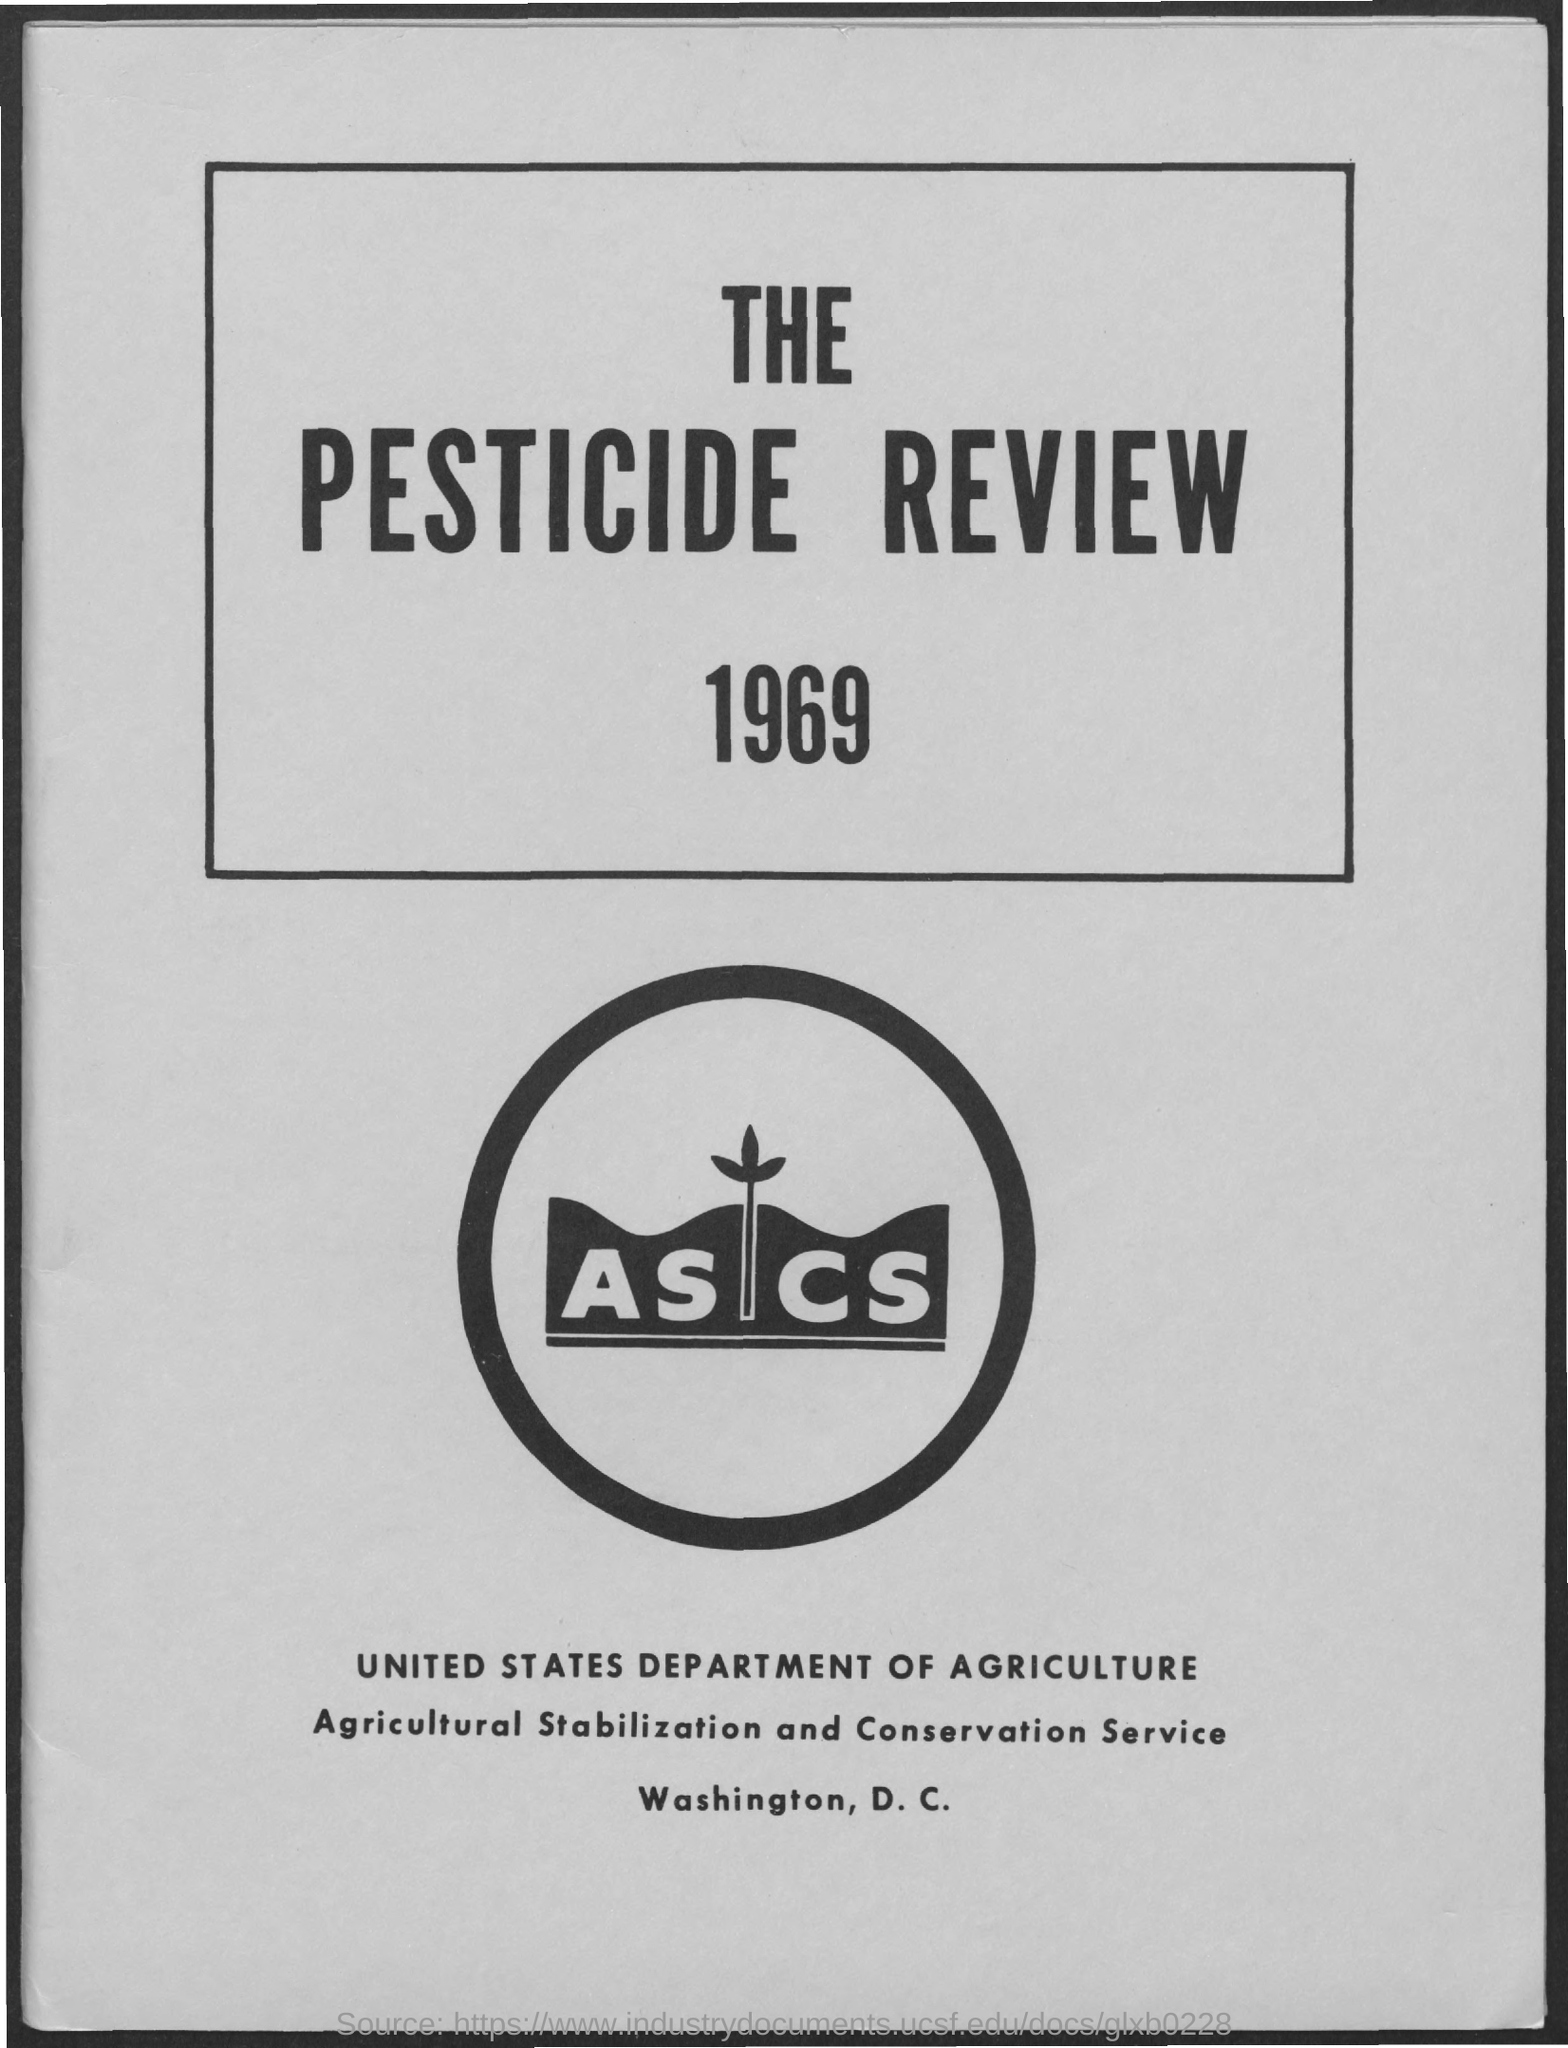What is the name of department mentioned ?
Offer a terse response. United states department of agriculture. 